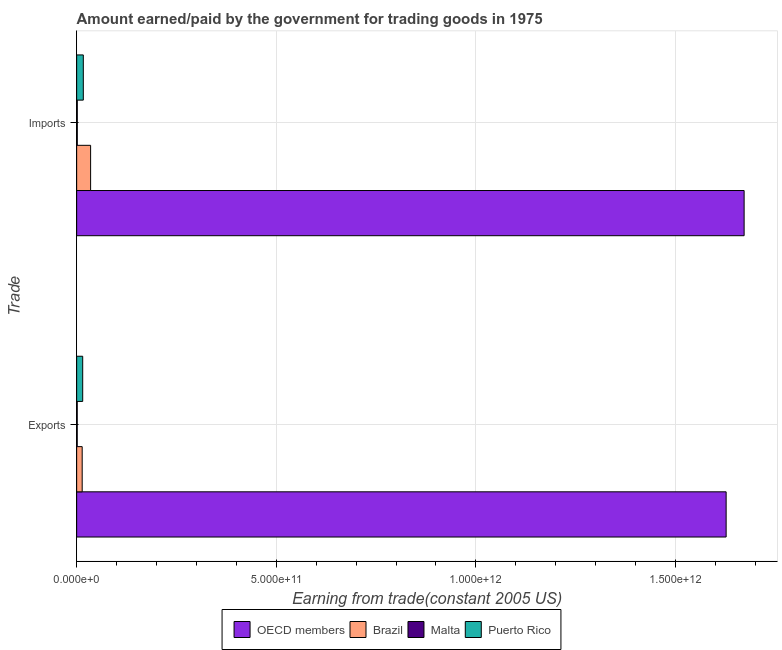How many groups of bars are there?
Your answer should be compact. 2. Are the number of bars on each tick of the Y-axis equal?
Ensure brevity in your answer.  Yes. What is the label of the 1st group of bars from the top?
Ensure brevity in your answer.  Imports. What is the amount earned from exports in Malta?
Provide a short and direct response. 1.40e+09. Across all countries, what is the maximum amount paid for imports?
Give a very brief answer. 1.67e+12. Across all countries, what is the minimum amount earned from exports?
Make the answer very short. 1.40e+09. In which country was the amount earned from exports maximum?
Your answer should be very brief. OECD members. In which country was the amount earned from exports minimum?
Make the answer very short. Malta. What is the total amount earned from exports in the graph?
Your answer should be compact. 1.66e+12. What is the difference between the amount paid for imports in OECD members and that in Brazil?
Your response must be concise. 1.64e+12. What is the difference between the amount earned from exports in Malta and the amount paid for imports in Brazil?
Keep it short and to the point. -3.35e+1. What is the average amount earned from exports per country?
Make the answer very short. 4.14e+11. What is the difference between the amount earned from exports and amount paid for imports in OECD members?
Your answer should be compact. -4.50e+1. What is the ratio of the amount earned from exports in OECD members to that in Puerto Rico?
Ensure brevity in your answer.  107.42. Is the amount earned from exports in OECD members less than that in Malta?
Offer a terse response. No. What does the 3rd bar from the bottom in Exports represents?
Your answer should be compact. Malta. How many countries are there in the graph?
Provide a succinct answer. 4. What is the difference between two consecutive major ticks on the X-axis?
Keep it short and to the point. 5.00e+11. Does the graph contain any zero values?
Give a very brief answer. No. What is the title of the graph?
Your response must be concise. Amount earned/paid by the government for trading goods in 1975. Does "South Sudan" appear as one of the legend labels in the graph?
Make the answer very short. No. What is the label or title of the X-axis?
Ensure brevity in your answer.  Earning from trade(constant 2005 US). What is the label or title of the Y-axis?
Keep it short and to the point. Trade. What is the Earning from trade(constant 2005 US) of OECD members in Exports?
Keep it short and to the point. 1.63e+12. What is the Earning from trade(constant 2005 US) of Brazil in Exports?
Your answer should be very brief. 1.38e+1. What is the Earning from trade(constant 2005 US) of Malta in Exports?
Provide a succinct answer. 1.40e+09. What is the Earning from trade(constant 2005 US) of Puerto Rico in Exports?
Your answer should be very brief. 1.51e+1. What is the Earning from trade(constant 2005 US) of OECD members in Imports?
Give a very brief answer. 1.67e+12. What is the Earning from trade(constant 2005 US) of Brazil in Imports?
Your answer should be compact. 3.49e+1. What is the Earning from trade(constant 2005 US) of Malta in Imports?
Offer a terse response. 1.56e+09. What is the Earning from trade(constant 2005 US) in Puerto Rico in Imports?
Your answer should be compact. 1.67e+1. Across all Trade, what is the maximum Earning from trade(constant 2005 US) of OECD members?
Offer a terse response. 1.67e+12. Across all Trade, what is the maximum Earning from trade(constant 2005 US) in Brazil?
Your response must be concise. 3.49e+1. Across all Trade, what is the maximum Earning from trade(constant 2005 US) in Malta?
Offer a very short reply. 1.56e+09. Across all Trade, what is the maximum Earning from trade(constant 2005 US) of Puerto Rico?
Keep it short and to the point. 1.67e+1. Across all Trade, what is the minimum Earning from trade(constant 2005 US) in OECD members?
Your answer should be compact. 1.63e+12. Across all Trade, what is the minimum Earning from trade(constant 2005 US) in Brazil?
Ensure brevity in your answer.  1.38e+1. Across all Trade, what is the minimum Earning from trade(constant 2005 US) of Malta?
Your answer should be compact. 1.40e+09. Across all Trade, what is the minimum Earning from trade(constant 2005 US) in Puerto Rico?
Your answer should be very brief. 1.51e+1. What is the total Earning from trade(constant 2005 US) of OECD members in the graph?
Your answer should be compact. 3.30e+12. What is the total Earning from trade(constant 2005 US) of Brazil in the graph?
Provide a succinct answer. 4.88e+1. What is the total Earning from trade(constant 2005 US) in Malta in the graph?
Offer a very short reply. 2.97e+09. What is the total Earning from trade(constant 2005 US) in Puerto Rico in the graph?
Make the answer very short. 3.18e+1. What is the difference between the Earning from trade(constant 2005 US) of OECD members in Exports and that in Imports?
Make the answer very short. -4.50e+1. What is the difference between the Earning from trade(constant 2005 US) in Brazil in Exports and that in Imports?
Make the answer very short. -2.11e+1. What is the difference between the Earning from trade(constant 2005 US) in Malta in Exports and that in Imports?
Ensure brevity in your answer.  -1.63e+08. What is the difference between the Earning from trade(constant 2005 US) of Puerto Rico in Exports and that in Imports?
Provide a succinct answer. -1.51e+09. What is the difference between the Earning from trade(constant 2005 US) of OECD members in Exports and the Earning from trade(constant 2005 US) of Brazil in Imports?
Keep it short and to the point. 1.59e+12. What is the difference between the Earning from trade(constant 2005 US) in OECD members in Exports and the Earning from trade(constant 2005 US) in Malta in Imports?
Offer a terse response. 1.63e+12. What is the difference between the Earning from trade(constant 2005 US) of OECD members in Exports and the Earning from trade(constant 2005 US) of Puerto Rico in Imports?
Provide a succinct answer. 1.61e+12. What is the difference between the Earning from trade(constant 2005 US) of Brazil in Exports and the Earning from trade(constant 2005 US) of Malta in Imports?
Ensure brevity in your answer.  1.23e+1. What is the difference between the Earning from trade(constant 2005 US) in Brazil in Exports and the Earning from trade(constant 2005 US) in Puerto Rico in Imports?
Ensure brevity in your answer.  -2.82e+09. What is the difference between the Earning from trade(constant 2005 US) of Malta in Exports and the Earning from trade(constant 2005 US) of Puerto Rico in Imports?
Your answer should be very brief. -1.53e+1. What is the average Earning from trade(constant 2005 US) in OECD members per Trade?
Make the answer very short. 1.65e+12. What is the average Earning from trade(constant 2005 US) of Brazil per Trade?
Ensure brevity in your answer.  2.44e+1. What is the average Earning from trade(constant 2005 US) in Malta per Trade?
Offer a very short reply. 1.48e+09. What is the average Earning from trade(constant 2005 US) in Puerto Rico per Trade?
Offer a very short reply. 1.59e+1. What is the difference between the Earning from trade(constant 2005 US) of OECD members and Earning from trade(constant 2005 US) of Brazil in Exports?
Your answer should be compact. 1.61e+12. What is the difference between the Earning from trade(constant 2005 US) of OECD members and Earning from trade(constant 2005 US) of Malta in Exports?
Make the answer very short. 1.63e+12. What is the difference between the Earning from trade(constant 2005 US) in OECD members and Earning from trade(constant 2005 US) in Puerto Rico in Exports?
Keep it short and to the point. 1.61e+12. What is the difference between the Earning from trade(constant 2005 US) in Brazil and Earning from trade(constant 2005 US) in Malta in Exports?
Ensure brevity in your answer.  1.24e+1. What is the difference between the Earning from trade(constant 2005 US) of Brazil and Earning from trade(constant 2005 US) of Puerto Rico in Exports?
Provide a succinct answer. -1.31e+09. What is the difference between the Earning from trade(constant 2005 US) of Malta and Earning from trade(constant 2005 US) of Puerto Rico in Exports?
Make the answer very short. -1.37e+1. What is the difference between the Earning from trade(constant 2005 US) of OECD members and Earning from trade(constant 2005 US) of Brazil in Imports?
Provide a succinct answer. 1.64e+12. What is the difference between the Earning from trade(constant 2005 US) in OECD members and Earning from trade(constant 2005 US) in Malta in Imports?
Your answer should be very brief. 1.67e+12. What is the difference between the Earning from trade(constant 2005 US) of OECD members and Earning from trade(constant 2005 US) of Puerto Rico in Imports?
Provide a short and direct response. 1.66e+12. What is the difference between the Earning from trade(constant 2005 US) in Brazil and Earning from trade(constant 2005 US) in Malta in Imports?
Ensure brevity in your answer.  3.34e+1. What is the difference between the Earning from trade(constant 2005 US) in Brazil and Earning from trade(constant 2005 US) in Puerto Rico in Imports?
Offer a terse response. 1.83e+1. What is the difference between the Earning from trade(constant 2005 US) in Malta and Earning from trade(constant 2005 US) in Puerto Rico in Imports?
Give a very brief answer. -1.51e+1. What is the ratio of the Earning from trade(constant 2005 US) in OECD members in Exports to that in Imports?
Your answer should be very brief. 0.97. What is the ratio of the Earning from trade(constant 2005 US) in Brazil in Exports to that in Imports?
Keep it short and to the point. 0.4. What is the ratio of the Earning from trade(constant 2005 US) in Malta in Exports to that in Imports?
Your answer should be very brief. 0.9. What is the ratio of the Earning from trade(constant 2005 US) in Puerto Rico in Exports to that in Imports?
Your answer should be very brief. 0.91. What is the difference between the highest and the second highest Earning from trade(constant 2005 US) in OECD members?
Ensure brevity in your answer.  4.50e+1. What is the difference between the highest and the second highest Earning from trade(constant 2005 US) in Brazil?
Make the answer very short. 2.11e+1. What is the difference between the highest and the second highest Earning from trade(constant 2005 US) in Malta?
Give a very brief answer. 1.63e+08. What is the difference between the highest and the second highest Earning from trade(constant 2005 US) of Puerto Rico?
Your answer should be very brief. 1.51e+09. What is the difference between the highest and the lowest Earning from trade(constant 2005 US) in OECD members?
Give a very brief answer. 4.50e+1. What is the difference between the highest and the lowest Earning from trade(constant 2005 US) in Brazil?
Provide a succinct answer. 2.11e+1. What is the difference between the highest and the lowest Earning from trade(constant 2005 US) in Malta?
Keep it short and to the point. 1.63e+08. What is the difference between the highest and the lowest Earning from trade(constant 2005 US) of Puerto Rico?
Your response must be concise. 1.51e+09. 